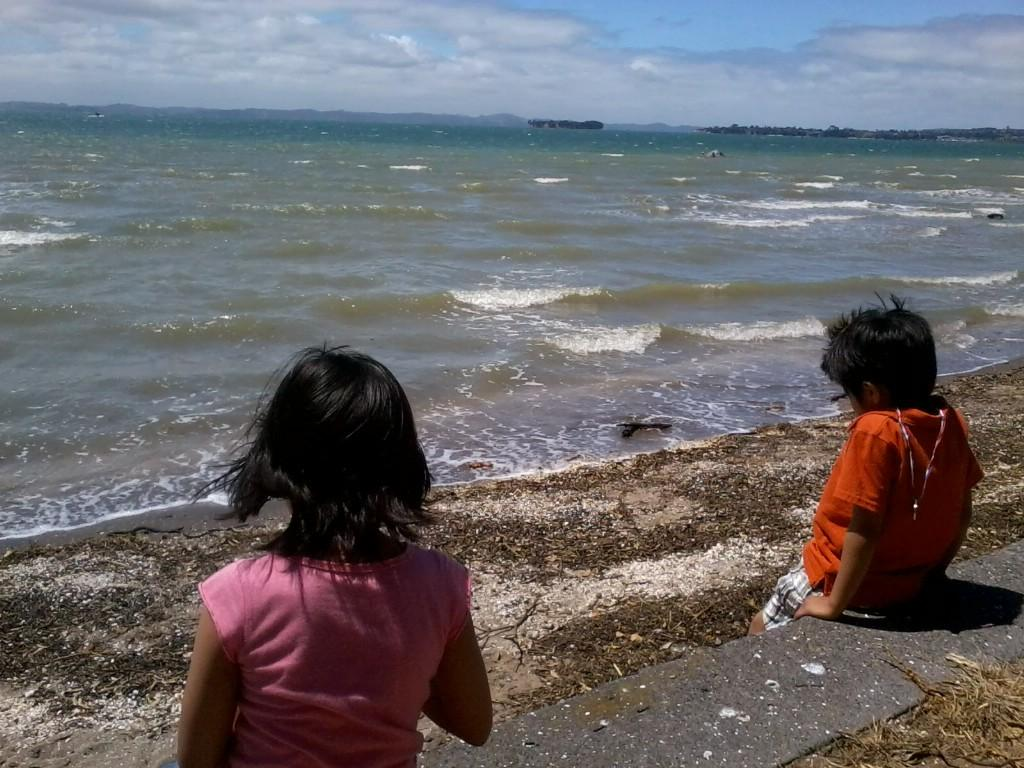Who can be seen in the image? There is a girl and a boy in the image. What are they doing in the image? They are sitting on a platform. What can be seen in the background of the image? Water, trees, mountains, and clouds are visible in the background. What type of trains can be seen passing by in the image? There are no trains present in the image. What class are the children attending while sitting on the platform? There is no indication in the image that the children are attending a class. 